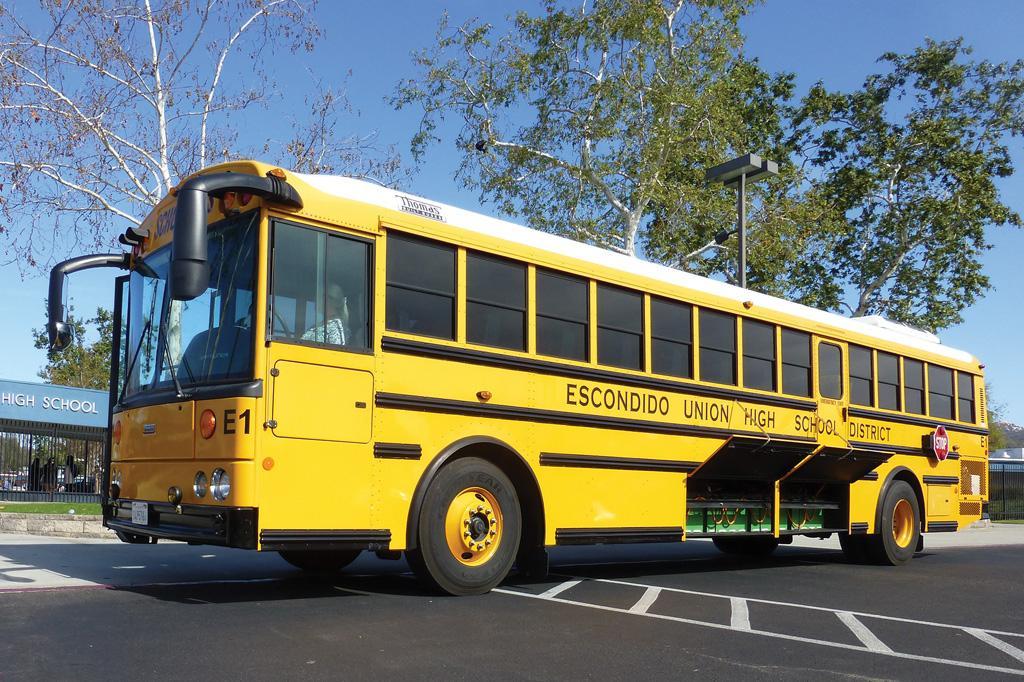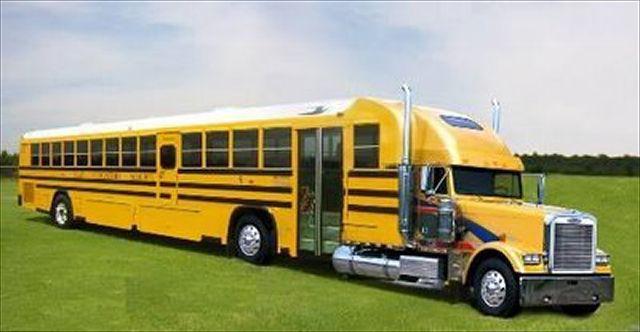The first image is the image on the left, the second image is the image on the right. For the images displayed, is the sentence "Each image contains one bus that has a non-flat front and is parked at a leftward angle, with the red sign on its side facing the camera." factually correct? Answer yes or no. No. The first image is the image on the left, the second image is the image on the right. Examine the images to the left and right. Is the description "Every school bus is pointing to the left." accurate? Answer yes or no. No. 